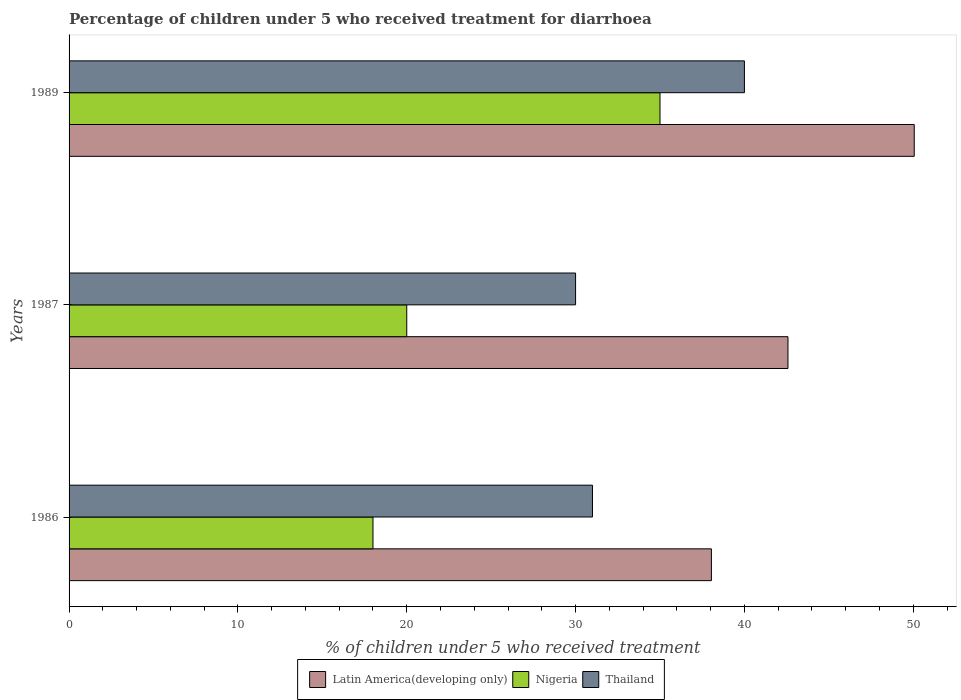In how many cases, is the number of bars for a given year not equal to the number of legend labels?
Offer a very short reply. 0. What is the percentage of children who received treatment for diarrhoea  in Latin America(developing only) in 1987?
Keep it short and to the point. 42.58. Across all years, what is the maximum percentage of children who received treatment for diarrhoea  in Latin America(developing only)?
Give a very brief answer. 50.06. In which year was the percentage of children who received treatment for diarrhoea  in Thailand maximum?
Keep it short and to the point. 1989. In which year was the percentage of children who received treatment for diarrhoea  in Latin America(developing only) minimum?
Your response must be concise. 1986. What is the total percentage of children who received treatment for diarrhoea  in Nigeria in the graph?
Provide a succinct answer. 73. What is the difference between the percentage of children who received treatment for diarrhoea  in Latin America(developing only) in 1987 and that in 1989?
Your answer should be compact. -7.48. What is the difference between the percentage of children who received treatment for diarrhoea  in Latin America(developing only) in 1987 and the percentage of children who received treatment for diarrhoea  in Nigeria in 1989?
Ensure brevity in your answer.  7.58. What is the average percentage of children who received treatment for diarrhoea  in Latin America(developing only) per year?
Your answer should be very brief. 43.56. What is the ratio of the percentage of children who received treatment for diarrhoea  in Thailand in 1987 to that in 1989?
Give a very brief answer. 0.75. Is the percentage of children who received treatment for diarrhoea  in Latin America(developing only) in 1986 less than that in 1989?
Keep it short and to the point. Yes. Is the difference between the percentage of children who received treatment for diarrhoea  in Thailand in 1986 and 1987 greater than the difference between the percentage of children who received treatment for diarrhoea  in Nigeria in 1986 and 1987?
Give a very brief answer. Yes. What is the difference between the highest and the lowest percentage of children who received treatment for diarrhoea  in Latin America(developing only)?
Give a very brief answer. 12.01. In how many years, is the percentage of children who received treatment for diarrhoea  in Latin America(developing only) greater than the average percentage of children who received treatment for diarrhoea  in Latin America(developing only) taken over all years?
Make the answer very short. 1. Is the sum of the percentage of children who received treatment for diarrhoea  in Nigeria in 1986 and 1987 greater than the maximum percentage of children who received treatment for diarrhoea  in Thailand across all years?
Keep it short and to the point. No. What does the 2nd bar from the top in 1986 represents?
Your answer should be very brief. Nigeria. What does the 2nd bar from the bottom in 1989 represents?
Your answer should be very brief. Nigeria. How many bars are there?
Ensure brevity in your answer.  9. How many years are there in the graph?
Make the answer very short. 3. What is the difference between two consecutive major ticks on the X-axis?
Offer a very short reply. 10. Does the graph contain any zero values?
Your answer should be very brief. No. How many legend labels are there?
Keep it short and to the point. 3. How are the legend labels stacked?
Offer a terse response. Horizontal. What is the title of the graph?
Make the answer very short. Percentage of children under 5 who received treatment for diarrhoea. What is the label or title of the X-axis?
Provide a succinct answer. % of children under 5 who received treatment. What is the label or title of the Y-axis?
Give a very brief answer. Years. What is the % of children under 5 who received treatment of Latin America(developing only) in 1986?
Offer a terse response. 38.04. What is the % of children under 5 who received treatment of Thailand in 1986?
Your answer should be very brief. 31. What is the % of children under 5 who received treatment of Latin America(developing only) in 1987?
Offer a terse response. 42.58. What is the % of children under 5 who received treatment in Thailand in 1987?
Your response must be concise. 30. What is the % of children under 5 who received treatment of Latin America(developing only) in 1989?
Your response must be concise. 50.06. What is the % of children under 5 who received treatment of Thailand in 1989?
Ensure brevity in your answer.  40. Across all years, what is the maximum % of children under 5 who received treatment in Latin America(developing only)?
Your answer should be compact. 50.06. Across all years, what is the maximum % of children under 5 who received treatment in Nigeria?
Ensure brevity in your answer.  35. Across all years, what is the maximum % of children under 5 who received treatment in Thailand?
Your answer should be very brief. 40. Across all years, what is the minimum % of children under 5 who received treatment of Latin America(developing only)?
Your response must be concise. 38.04. Across all years, what is the minimum % of children under 5 who received treatment of Nigeria?
Your response must be concise. 18. What is the total % of children under 5 who received treatment of Latin America(developing only) in the graph?
Keep it short and to the point. 130.68. What is the total % of children under 5 who received treatment in Thailand in the graph?
Provide a short and direct response. 101. What is the difference between the % of children under 5 who received treatment in Latin America(developing only) in 1986 and that in 1987?
Your answer should be very brief. -4.53. What is the difference between the % of children under 5 who received treatment in Latin America(developing only) in 1986 and that in 1989?
Ensure brevity in your answer.  -12.01. What is the difference between the % of children under 5 who received treatment of Nigeria in 1986 and that in 1989?
Keep it short and to the point. -17. What is the difference between the % of children under 5 who received treatment in Thailand in 1986 and that in 1989?
Your response must be concise. -9. What is the difference between the % of children under 5 who received treatment of Latin America(developing only) in 1987 and that in 1989?
Your response must be concise. -7.48. What is the difference between the % of children under 5 who received treatment of Thailand in 1987 and that in 1989?
Your response must be concise. -10. What is the difference between the % of children under 5 who received treatment in Latin America(developing only) in 1986 and the % of children under 5 who received treatment in Nigeria in 1987?
Your response must be concise. 18.04. What is the difference between the % of children under 5 who received treatment in Latin America(developing only) in 1986 and the % of children under 5 who received treatment in Thailand in 1987?
Provide a short and direct response. 8.04. What is the difference between the % of children under 5 who received treatment in Nigeria in 1986 and the % of children under 5 who received treatment in Thailand in 1987?
Your response must be concise. -12. What is the difference between the % of children under 5 who received treatment of Latin America(developing only) in 1986 and the % of children under 5 who received treatment of Nigeria in 1989?
Your answer should be very brief. 3.04. What is the difference between the % of children under 5 who received treatment in Latin America(developing only) in 1986 and the % of children under 5 who received treatment in Thailand in 1989?
Provide a short and direct response. -1.96. What is the difference between the % of children under 5 who received treatment of Nigeria in 1986 and the % of children under 5 who received treatment of Thailand in 1989?
Make the answer very short. -22. What is the difference between the % of children under 5 who received treatment in Latin America(developing only) in 1987 and the % of children under 5 who received treatment in Nigeria in 1989?
Offer a very short reply. 7.58. What is the difference between the % of children under 5 who received treatment of Latin America(developing only) in 1987 and the % of children under 5 who received treatment of Thailand in 1989?
Keep it short and to the point. 2.58. What is the average % of children under 5 who received treatment in Latin America(developing only) per year?
Offer a terse response. 43.56. What is the average % of children under 5 who received treatment in Nigeria per year?
Keep it short and to the point. 24.33. What is the average % of children under 5 who received treatment of Thailand per year?
Your answer should be very brief. 33.67. In the year 1986, what is the difference between the % of children under 5 who received treatment in Latin America(developing only) and % of children under 5 who received treatment in Nigeria?
Ensure brevity in your answer.  20.04. In the year 1986, what is the difference between the % of children under 5 who received treatment of Latin America(developing only) and % of children under 5 who received treatment of Thailand?
Offer a terse response. 7.04. In the year 1987, what is the difference between the % of children under 5 who received treatment in Latin America(developing only) and % of children under 5 who received treatment in Nigeria?
Ensure brevity in your answer.  22.58. In the year 1987, what is the difference between the % of children under 5 who received treatment in Latin America(developing only) and % of children under 5 who received treatment in Thailand?
Offer a terse response. 12.58. In the year 1987, what is the difference between the % of children under 5 who received treatment in Nigeria and % of children under 5 who received treatment in Thailand?
Give a very brief answer. -10. In the year 1989, what is the difference between the % of children under 5 who received treatment of Latin America(developing only) and % of children under 5 who received treatment of Nigeria?
Give a very brief answer. 15.06. In the year 1989, what is the difference between the % of children under 5 who received treatment in Latin America(developing only) and % of children under 5 who received treatment in Thailand?
Your answer should be compact. 10.06. In the year 1989, what is the difference between the % of children under 5 who received treatment of Nigeria and % of children under 5 who received treatment of Thailand?
Keep it short and to the point. -5. What is the ratio of the % of children under 5 who received treatment of Latin America(developing only) in 1986 to that in 1987?
Provide a short and direct response. 0.89. What is the ratio of the % of children under 5 who received treatment in Nigeria in 1986 to that in 1987?
Give a very brief answer. 0.9. What is the ratio of the % of children under 5 who received treatment of Thailand in 1986 to that in 1987?
Your response must be concise. 1.03. What is the ratio of the % of children under 5 who received treatment of Latin America(developing only) in 1986 to that in 1989?
Your response must be concise. 0.76. What is the ratio of the % of children under 5 who received treatment of Nigeria in 1986 to that in 1989?
Provide a short and direct response. 0.51. What is the ratio of the % of children under 5 who received treatment in Thailand in 1986 to that in 1989?
Offer a terse response. 0.78. What is the ratio of the % of children under 5 who received treatment of Latin America(developing only) in 1987 to that in 1989?
Give a very brief answer. 0.85. What is the ratio of the % of children under 5 who received treatment in Thailand in 1987 to that in 1989?
Ensure brevity in your answer.  0.75. What is the difference between the highest and the second highest % of children under 5 who received treatment of Latin America(developing only)?
Offer a very short reply. 7.48. What is the difference between the highest and the second highest % of children under 5 who received treatment of Nigeria?
Offer a terse response. 15. What is the difference between the highest and the second highest % of children under 5 who received treatment of Thailand?
Give a very brief answer. 9. What is the difference between the highest and the lowest % of children under 5 who received treatment in Latin America(developing only)?
Offer a terse response. 12.01. What is the difference between the highest and the lowest % of children under 5 who received treatment in Nigeria?
Offer a terse response. 17. What is the difference between the highest and the lowest % of children under 5 who received treatment of Thailand?
Make the answer very short. 10. 